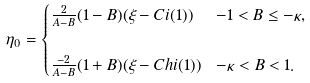<formula> <loc_0><loc_0><loc_500><loc_500>\eta _ { 0 } & = \begin{cases} \frac { 2 } { A - B } ( 1 - B ) ( \xi - C i ( 1 ) ) & - 1 < B \leq - \kappa , \\ & \\ \frac { - 2 } { A - B } ( 1 + B ) ( \xi - C h i ( 1 ) ) & - \kappa < B < 1 . \end{cases}</formula> 